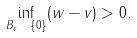Convert formula to latex. <formula><loc_0><loc_0><loc_500><loc_500>\inf _ { B _ { \epsilon } \ \{ 0 \} } ( w - v ) > 0 .</formula> 